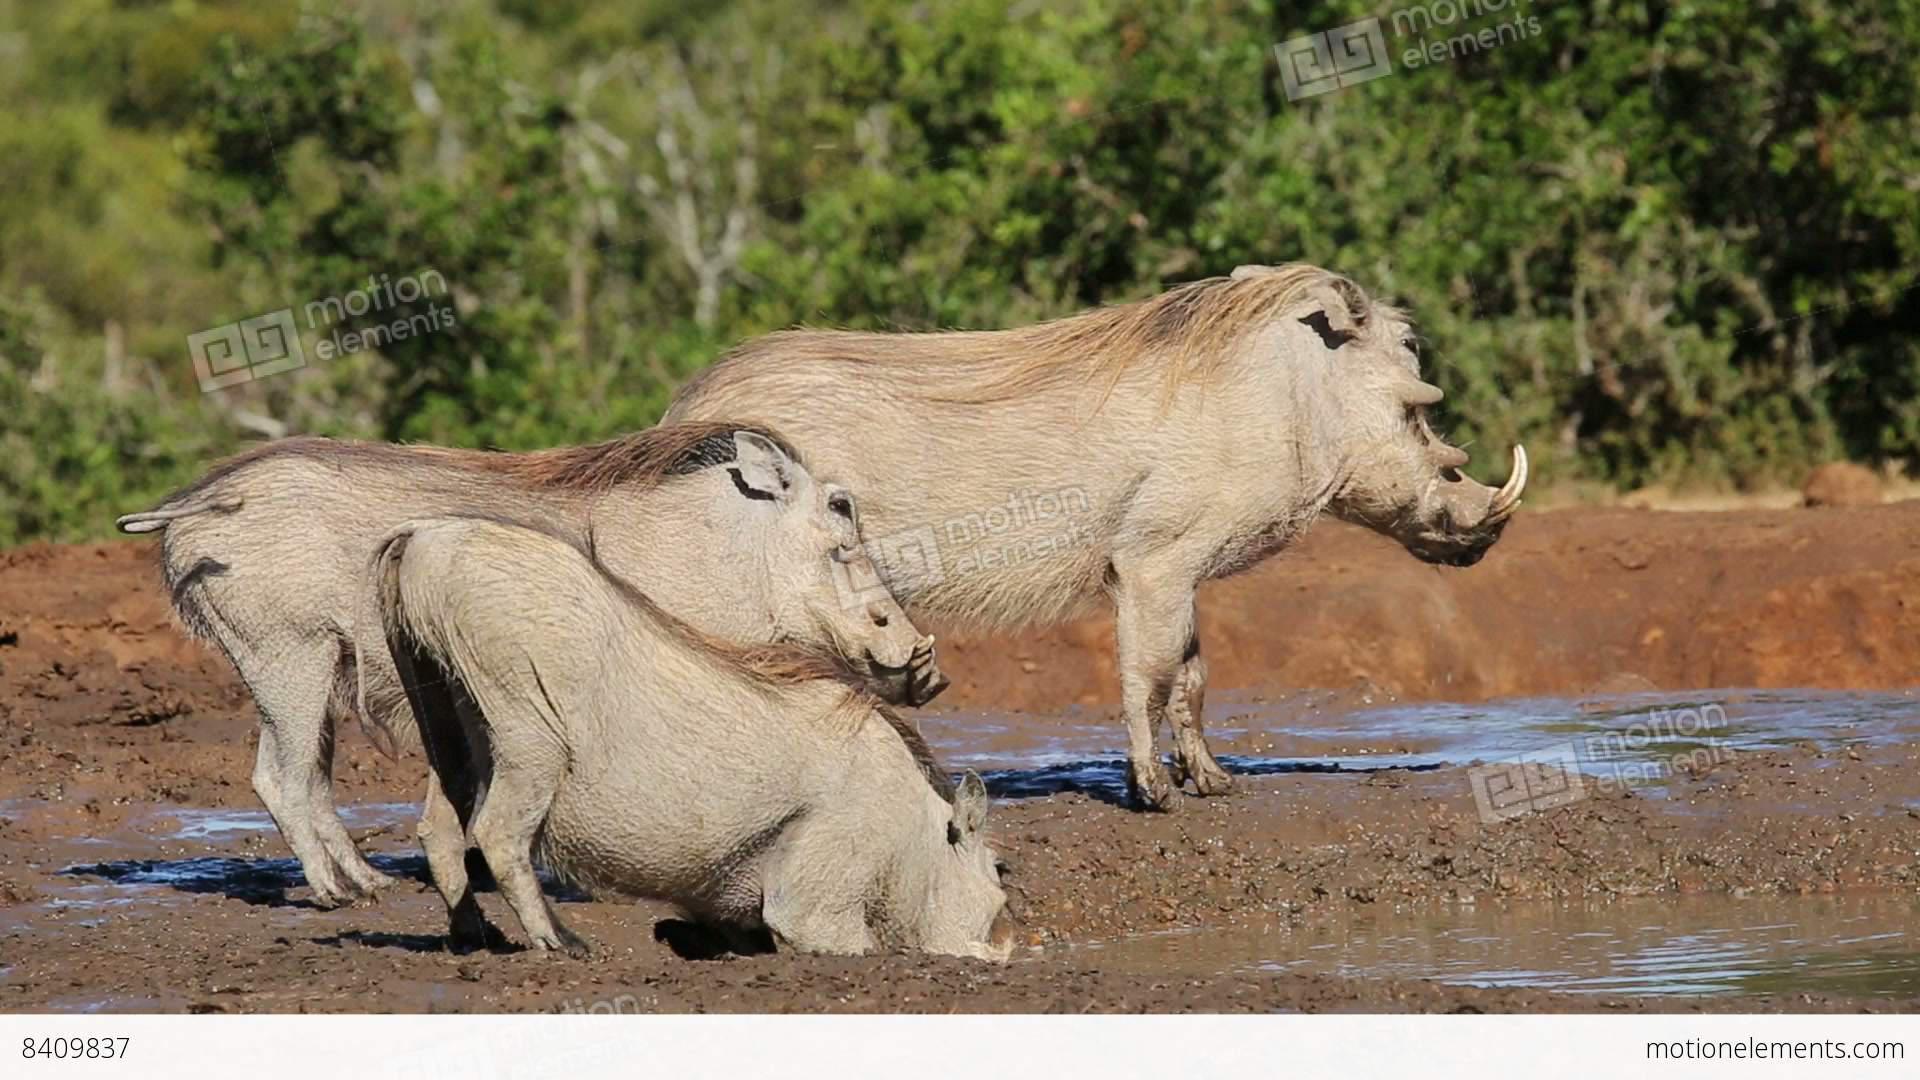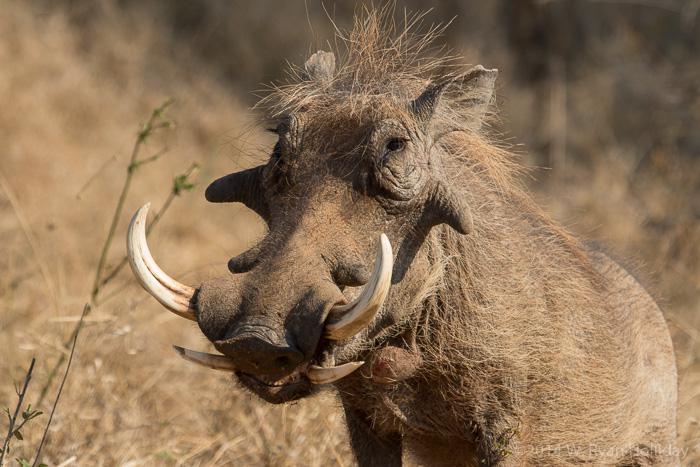The first image is the image on the left, the second image is the image on the right. Analyze the images presented: Is the assertion "the left image has at most 2 wartgogs" valid? Answer yes or no. No. The first image is the image on the left, the second image is the image on the right. Assess this claim about the two images: "In one image there are at least two warthogs drinking out of a pond.". Correct or not? Answer yes or no. No. 